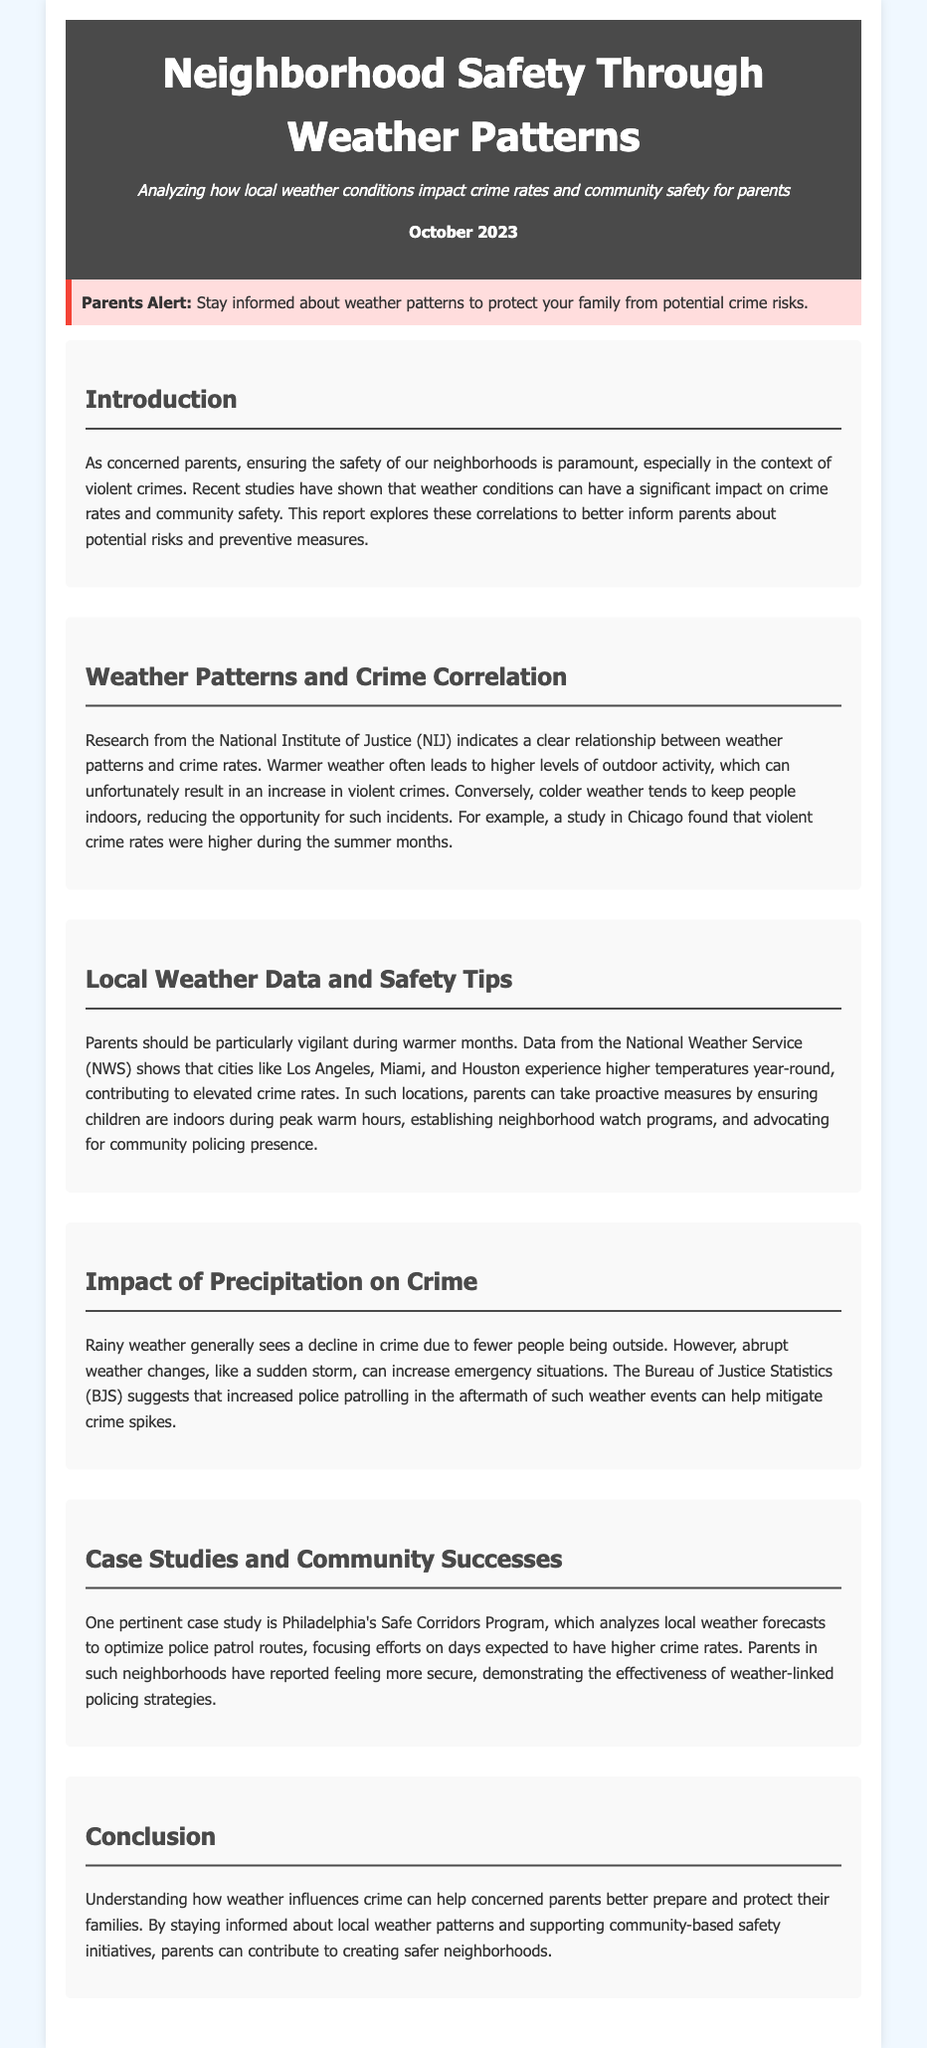What is the title of the document? The title is stated in the header section of the document.
Answer: Neighborhood Safety Through Weather Patterns What month and year is the report published? The publication date is mentioned in the header section.
Answer: October 2023 Which organization conducted research indicating a relationship between weather patterns and crime rates? The document specifies the organization that conducted the research.
Answer: National Institute of Justice What weather conditions lead to a decline in crime rates? The report discusses how weather conditions can affect crime rates.
Answer: Rainy weather What program is cited as a case study related to weather-linked policing strategies? The document provides a specific program as an example of community safety.
Answer: Philadelphia's Safe Corridors Program Which cities are mentioned as experiencing higher temperatures contributing to elevated crime rates? The document lists specific cities relevant to this issue.
Answer: Los Angeles, Miami, Houston What is one proactive measure parents can take during warmer months? The document suggests measures parents can implement to ensure safety.
Answer: Keeping children indoors How do abrupt weather changes impact emergency situations? The report explains the effects of weather changes on crime likelihood.
Answer: Increase crime spikes What does the Bureau of Justice Statistics suggest after sudden storms? The document addresses recommendations following abrupt weather changes.
Answer: Increased police patrolling 